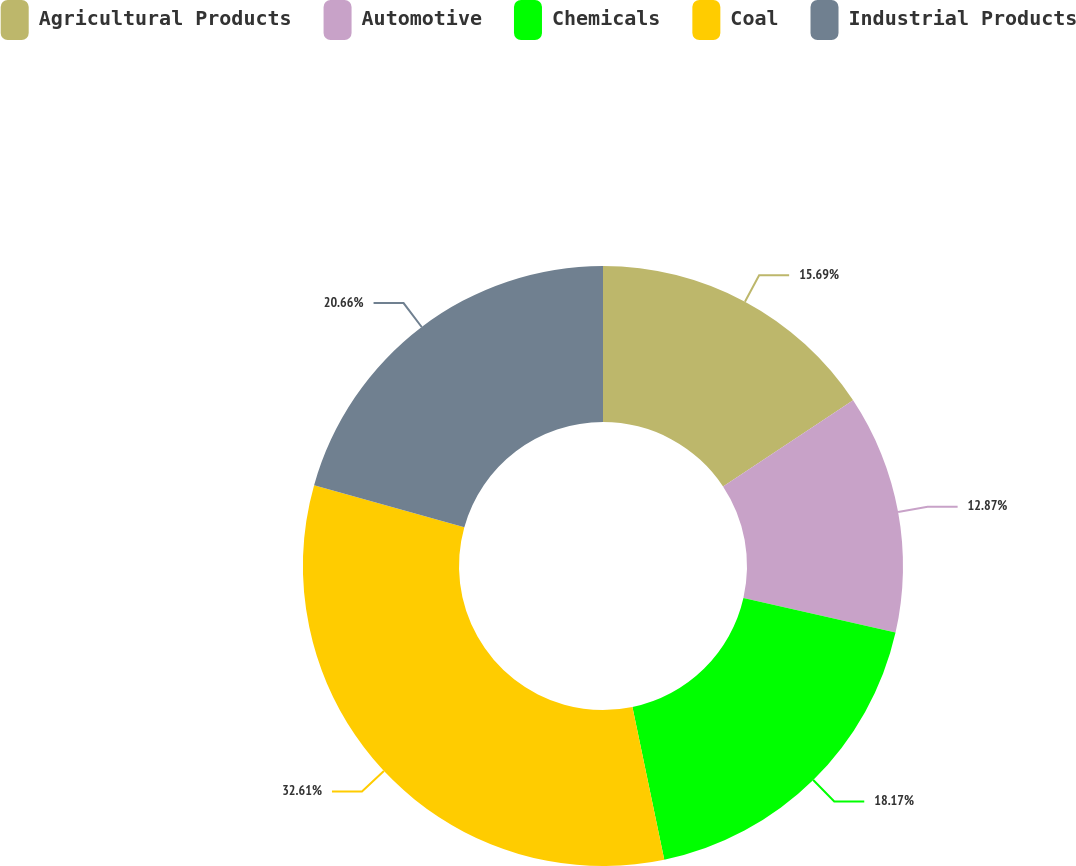Convert chart to OTSL. <chart><loc_0><loc_0><loc_500><loc_500><pie_chart><fcel>Agricultural Products<fcel>Automotive<fcel>Chemicals<fcel>Coal<fcel>Industrial Products<nl><fcel>15.69%<fcel>12.87%<fcel>18.17%<fcel>32.62%<fcel>20.66%<nl></chart> 